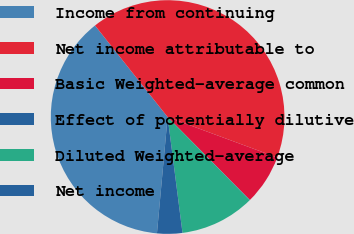Convert chart. <chart><loc_0><loc_0><loc_500><loc_500><pie_chart><fcel>Income from continuing<fcel>Net income attributable to<fcel>Basic Weighted-average common<fcel>Effect of potentially dilutive<fcel>Diluted Weighted-average<fcel>Net income<nl><fcel>37.87%<fcel>41.31%<fcel>6.93%<fcel>0.05%<fcel>10.36%<fcel>3.49%<nl></chart> 